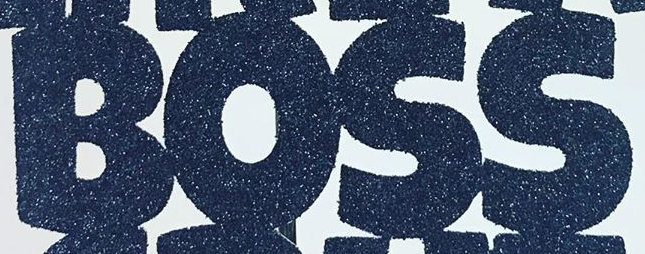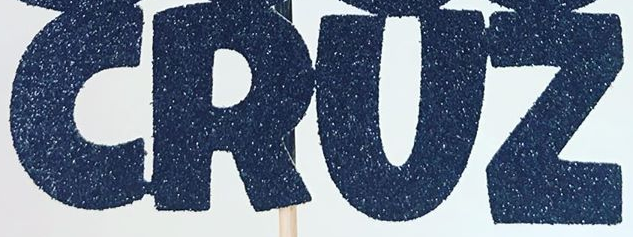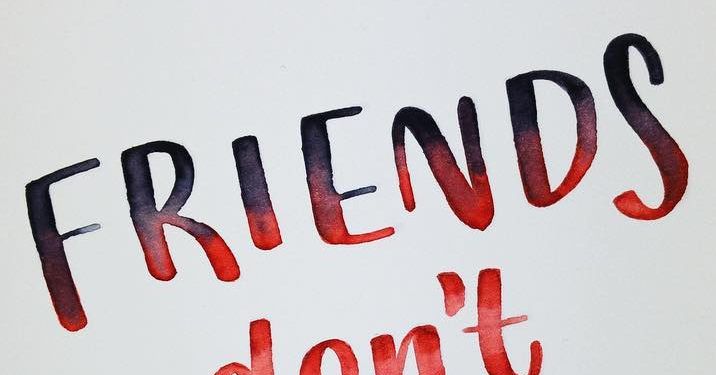Read the text from these images in sequence, separated by a semicolon. BOSS; CRUZ; FRIENDS 